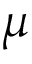<formula> <loc_0><loc_0><loc_500><loc_500>\mu</formula> 